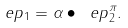<formula> <loc_0><loc_0><loc_500><loc_500>\ e p _ { 1 } = \alpha \bullet \ e p _ { 2 } ^ { \pi } .</formula> 